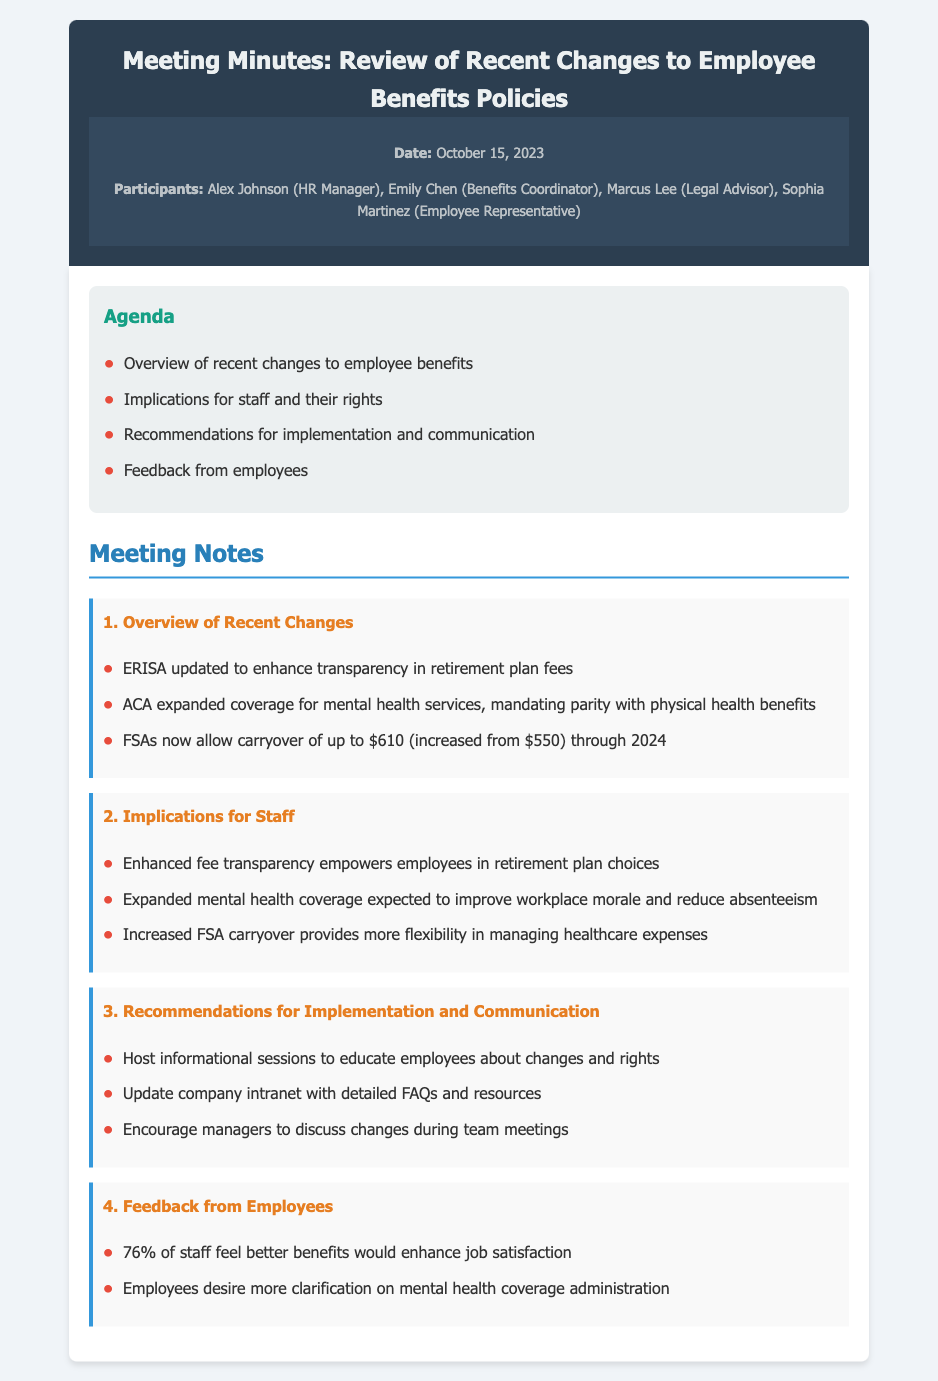What date was the meeting held? The date can be found in the meeting information section, stating "October 15, 2023."
Answer: October 15, 2023 Who is the Benefits Coordinator? The list of participants includes the role of Benefits Coordinator and the name associated with it.
Answer: Emily Chen What has been the increase in FSA carryover for 2024? The document mentions that the FSA carryover has increased from $550 to $610.
Answer: $60 What percentage of staff believes better benefits would enhance job satisfaction? The feedback section provides the specific percentage of staff who feel that way.
Answer: 76% What is mandated to be on par with physical health benefits? The document notes expanded mental health coverage is mandated to have parity.
Answer: Mental health services What is one recommendation for implementing changes? One of the recommendations mentioned is to "Host informational sessions."
Answer: Host informational sessions What information did Marcus Lee provide in the meeting? As a legal advisor, Marcus Lee provided insights on legal implications of the employee benefits.
Answer: Legal implications What does ACA stand for? ACA is referenced in the context of expanded coverage for mental health services in the meeting notes.
Answer: Affordable Care Act 